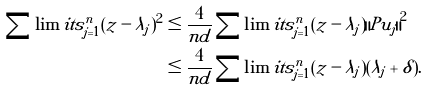Convert formula to latex. <formula><loc_0><loc_0><loc_500><loc_500>\sum \lim i t s _ { j = 1 } ^ { n } { ( z - \lambda _ { j } ) ^ { 2 } } & \leq \frac { 4 } { n d } \sum \lim i t s _ { j = 1 } ^ { n } { ( z - \lambda _ { j } ) { \| { P } u _ { j } \| } ^ { 2 } } \\ & \leq \frac { 4 } { n d } \sum \lim i t s _ { j = 1 } ^ { n } ( z - \lambda _ { j } ) ( \lambda _ { j } + \delta ) .</formula> 